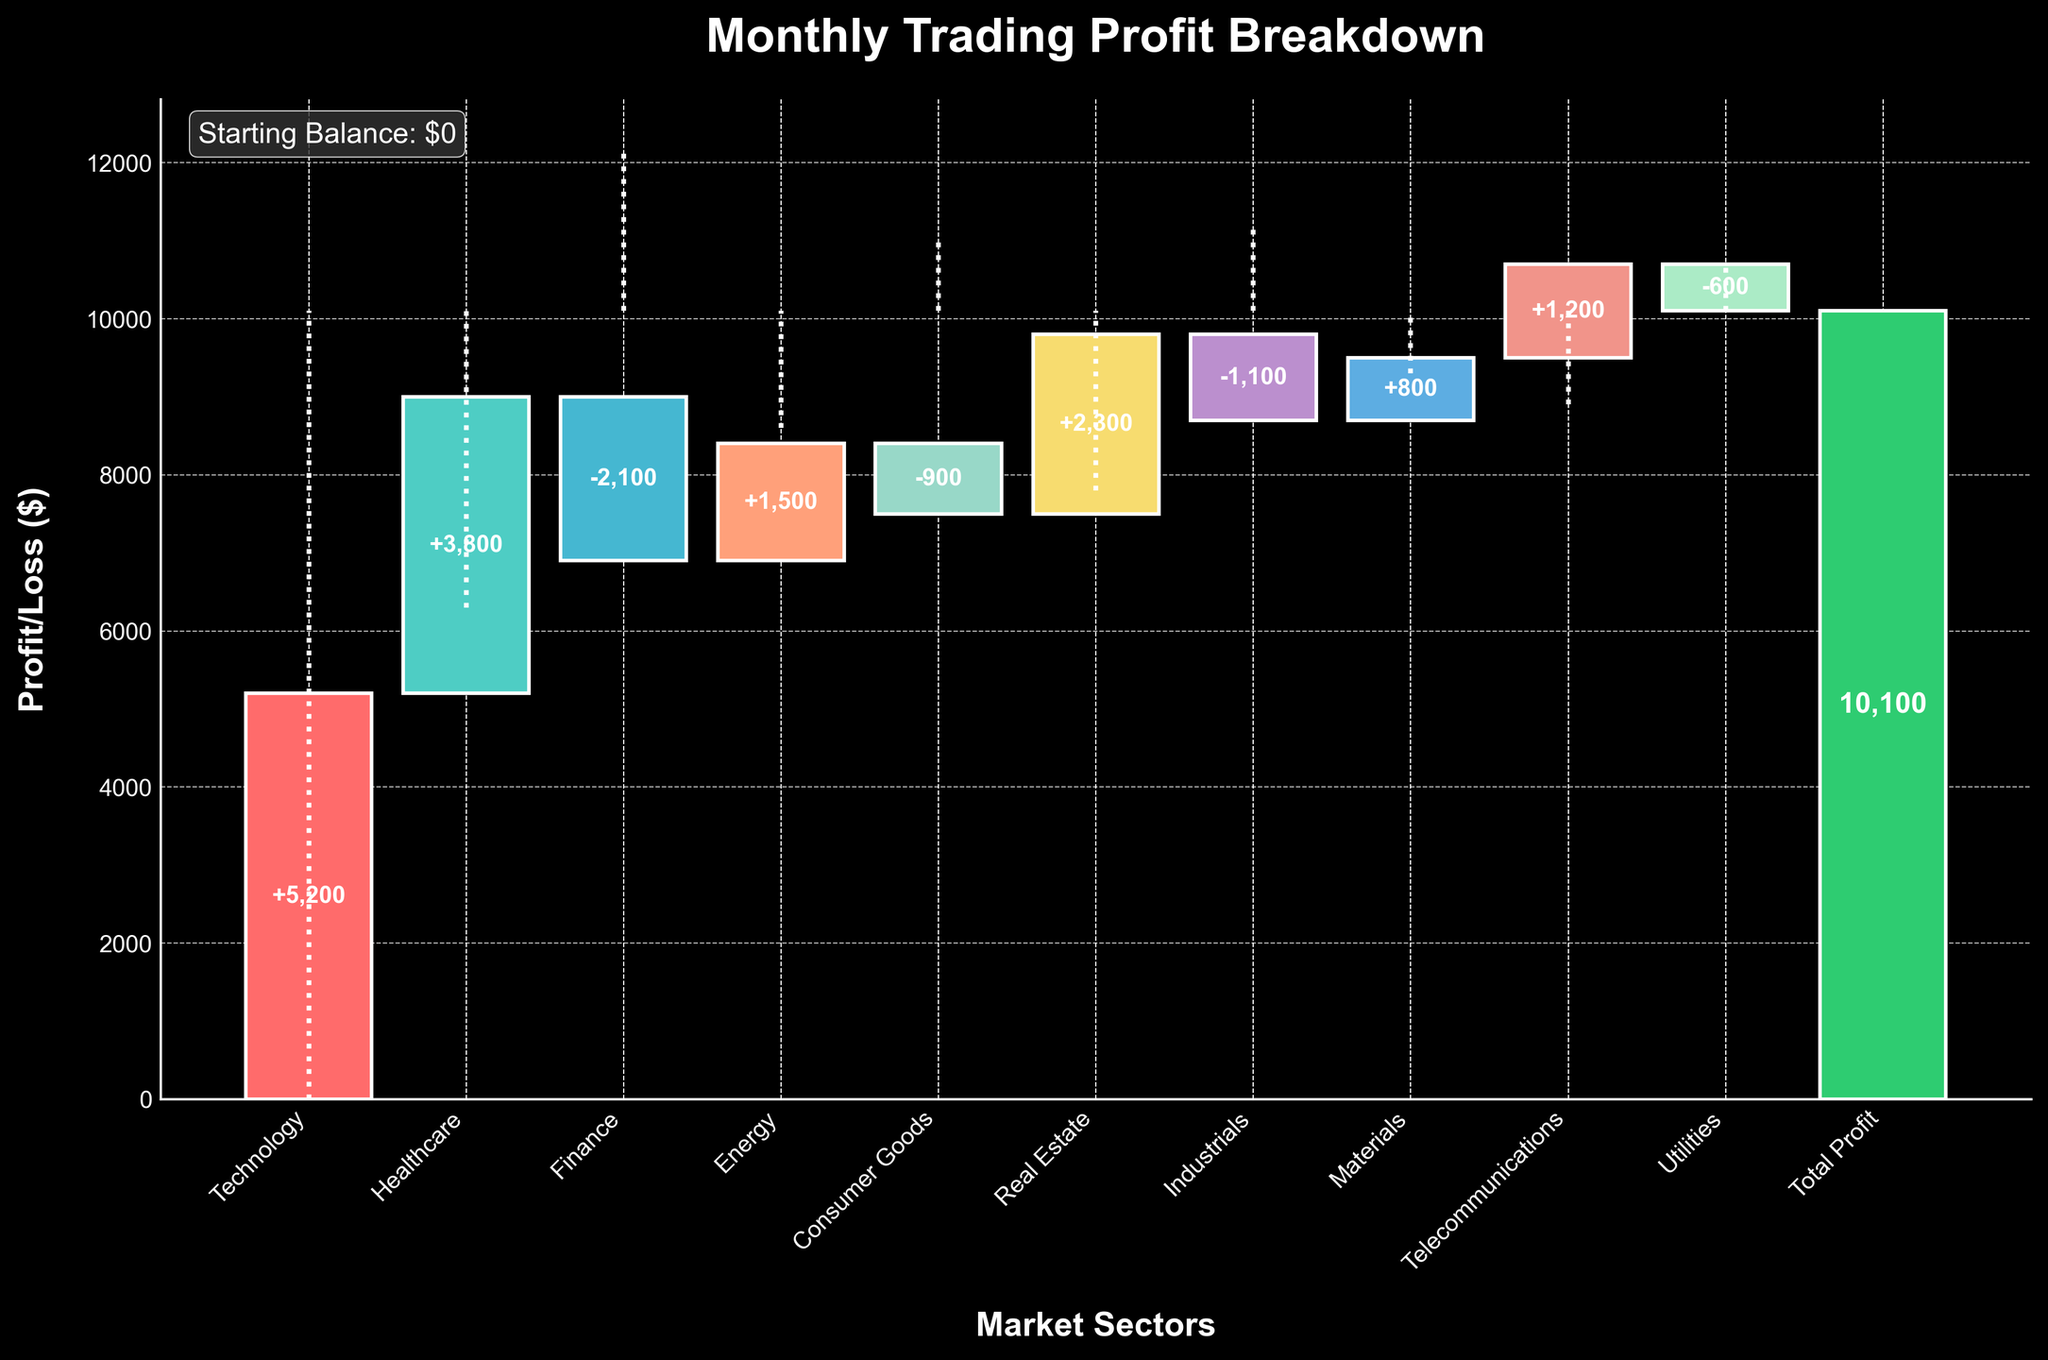What is the title of the chart? The title is positioned at the top of the chart, clearly stating the nature of the chart. It reads "Monthly Trading Profit Breakdown".
Answer: Monthly Trading Profit Breakdown How many market sectors are shown in the chart? By observing the x-axis labels, we can count the number of different market sectors listed. They include Technology, Healthcare, Finance, Energy, Consumer Goods, Real Estate, Industrials, Materials, Telecommunications, and Utilities.
Answer: 10 What is the contribution from the Technology sector? The bar labeled "Technology" shows a positive contribution, with a value annotated in the middle of the bar as "+5200".
Answer: +5200 Which sector had the most significant negative impact on the profit? By visually comparing the heights of the negative bars, the Finance sector shows the largest drop with an annotated value of "-2100".
Answer: Finance What is the total profit shown in the chart? The total profit is indicated by the last bar in the chart, which is labeled "Total Profit" and shows a value of "10100".
Answer: 10100 How does the contribution of the Energy sector compare to the Healthcare sector? The Energy sector has a positive contribution annotated as "+1500", whereas the Healthcare sector has a positive contribution annotated as "+3800". The Healthcare sector contributes more than the Energy sector.
Answer: Healthcare contributes more What is the cumulative profit after the HealthCare and Finance sectors are considered? Starting with the positive contribution from Healthcare (+3800), then adding the negative contribution from Finance (-2100), the cumulative profit after these two sectors is 3800 - 2100 = 1700.
Answer: 1700 What is the net contribution from sectors with negative impacts? Add the contributions from Finance (-2100), Consumer Goods (-900), Industrials (-1100), and Utilities (-600): -2100 + -900 + -1100 + -600 = -4700.
Answer: -4700 Which sectors have positive contributions above 2000? By checking the positive bars, Technology (+5200), Healthcare (+3800), and Real Estate (+2300) have contributions above 2000.
Answer: Technology, Healthcare, Real Estate How do positive and negative sectors balance out in terms of total profit? Sum up all positive contributions: 5200 (Tech) + 3800 (Healthcare) + 1500 (Energy) + 2300 (Real Estate) + 800 (Materials) + 1200 (Telecom) = 14800. Sum up all negative contributions: -2100 (Finance) - 900 (Consumer Goods) - 1100 (Industrials) - 600 (Utilities) = -4700. Net positive - Net negative = 14800 - 4700 = 10100.
Answer: 10100 